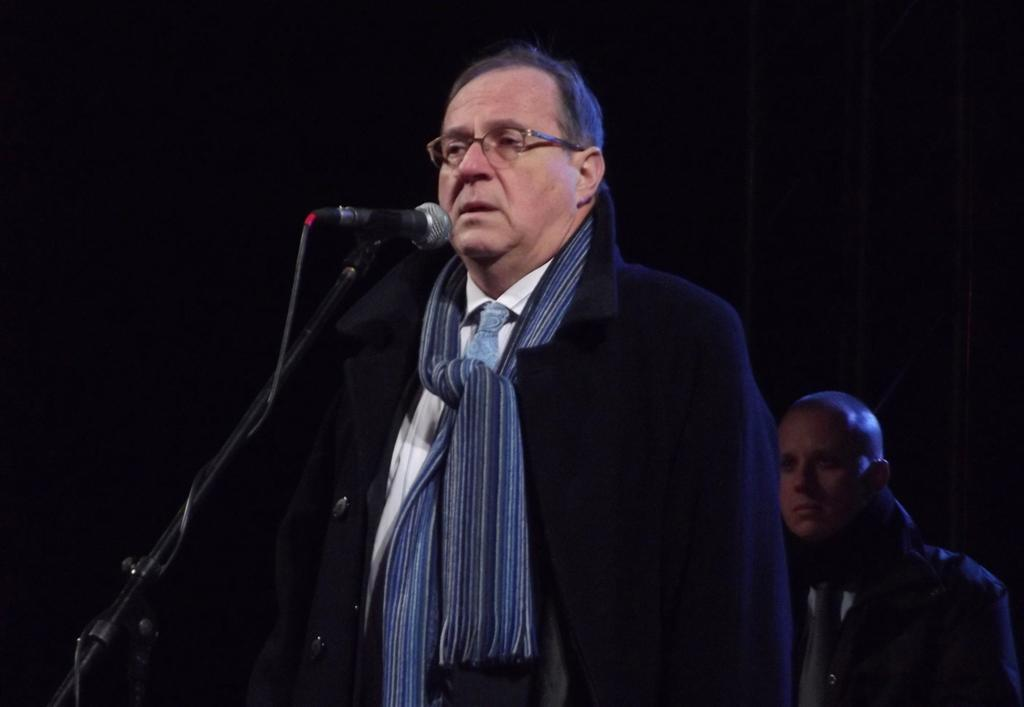Who is the main subject in the image? There is a man in the image. What is the man wearing? The man is wearing a suit. What is the man doing in the image? The man is standing in front of a mic. Can you describe the setting of the image? There is another man in the background of the image. What type of ground is visible beneath the man in the image? There is no ground visible in the image; it appears to be an indoor setting. What invention is the man holding in his hand in the image? The man is not holding any invention in his hand in the image; he is standing in front of a mic. 